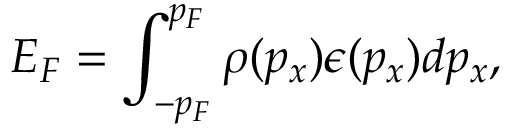<formula> <loc_0><loc_0><loc_500><loc_500>E _ { F } = \int _ { - p _ { F } } ^ { p _ { F } } \rho ( p _ { x } ) \epsilon ( p _ { x } ) d p _ { x } ,</formula> 